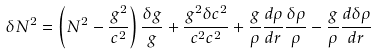<formula> <loc_0><loc_0><loc_500><loc_500>\delta N ^ { 2 } = \left ( N ^ { 2 } - \frac { g ^ { 2 } } { c ^ { 2 } } \right ) \frac { \delta g } { g } + \frac { g ^ { 2 } \delta c ^ { 2 } } { c ^ { 2 } c ^ { 2 } } + \frac { g } { \rho } \frac { d \rho } { d r } \frac { \delta \rho } { \rho } - \frac { g } { \rho } \frac { d \delta \rho } { d r }</formula> 